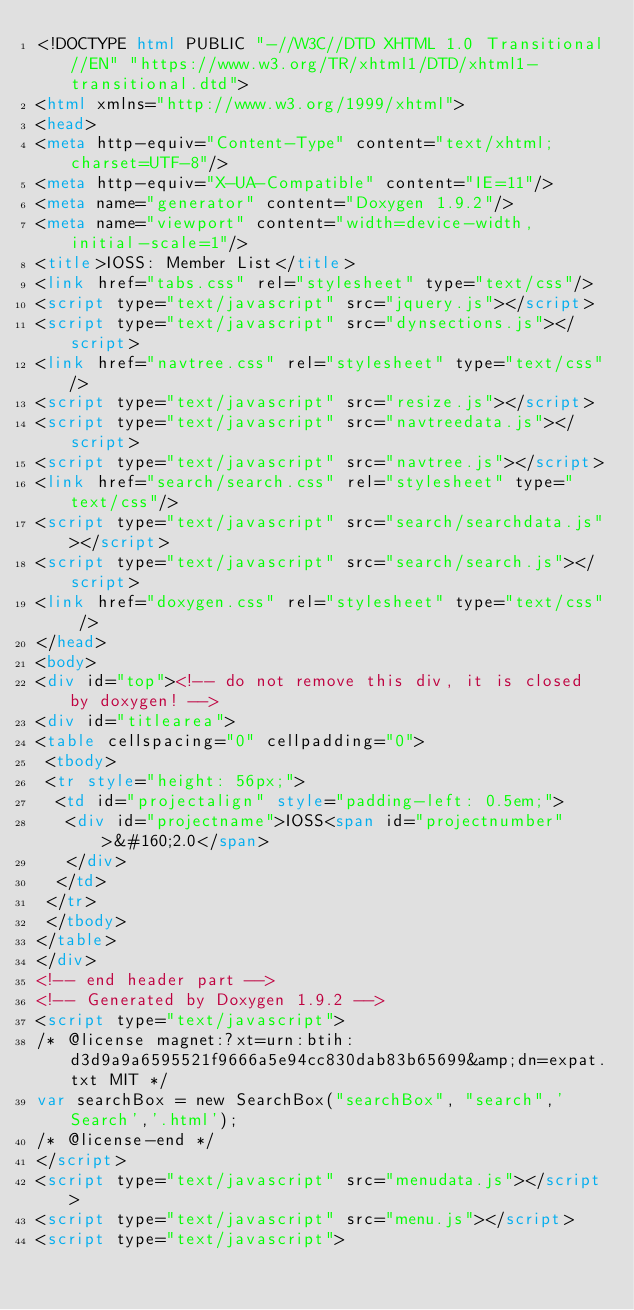<code> <loc_0><loc_0><loc_500><loc_500><_HTML_><!DOCTYPE html PUBLIC "-//W3C//DTD XHTML 1.0 Transitional//EN" "https://www.w3.org/TR/xhtml1/DTD/xhtml1-transitional.dtd">
<html xmlns="http://www.w3.org/1999/xhtml">
<head>
<meta http-equiv="Content-Type" content="text/xhtml;charset=UTF-8"/>
<meta http-equiv="X-UA-Compatible" content="IE=11"/>
<meta name="generator" content="Doxygen 1.9.2"/>
<meta name="viewport" content="width=device-width, initial-scale=1"/>
<title>IOSS: Member List</title>
<link href="tabs.css" rel="stylesheet" type="text/css"/>
<script type="text/javascript" src="jquery.js"></script>
<script type="text/javascript" src="dynsections.js"></script>
<link href="navtree.css" rel="stylesheet" type="text/css"/>
<script type="text/javascript" src="resize.js"></script>
<script type="text/javascript" src="navtreedata.js"></script>
<script type="text/javascript" src="navtree.js"></script>
<link href="search/search.css" rel="stylesheet" type="text/css"/>
<script type="text/javascript" src="search/searchdata.js"></script>
<script type="text/javascript" src="search/search.js"></script>
<link href="doxygen.css" rel="stylesheet" type="text/css" />
</head>
<body>
<div id="top"><!-- do not remove this div, it is closed by doxygen! -->
<div id="titlearea">
<table cellspacing="0" cellpadding="0">
 <tbody>
 <tr style="height: 56px;">
  <td id="projectalign" style="padding-left: 0.5em;">
   <div id="projectname">IOSS<span id="projectnumber">&#160;2.0</span>
   </div>
  </td>
 </tr>
 </tbody>
</table>
</div>
<!-- end header part -->
<!-- Generated by Doxygen 1.9.2 -->
<script type="text/javascript">
/* @license magnet:?xt=urn:btih:d3d9a9a6595521f9666a5e94cc830dab83b65699&amp;dn=expat.txt MIT */
var searchBox = new SearchBox("searchBox", "search",'Search','.html');
/* @license-end */
</script>
<script type="text/javascript" src="menudata.js"></script>
<script type="text/javascript" src="menu.js"></script>
<script type="text/javascript"></code> 